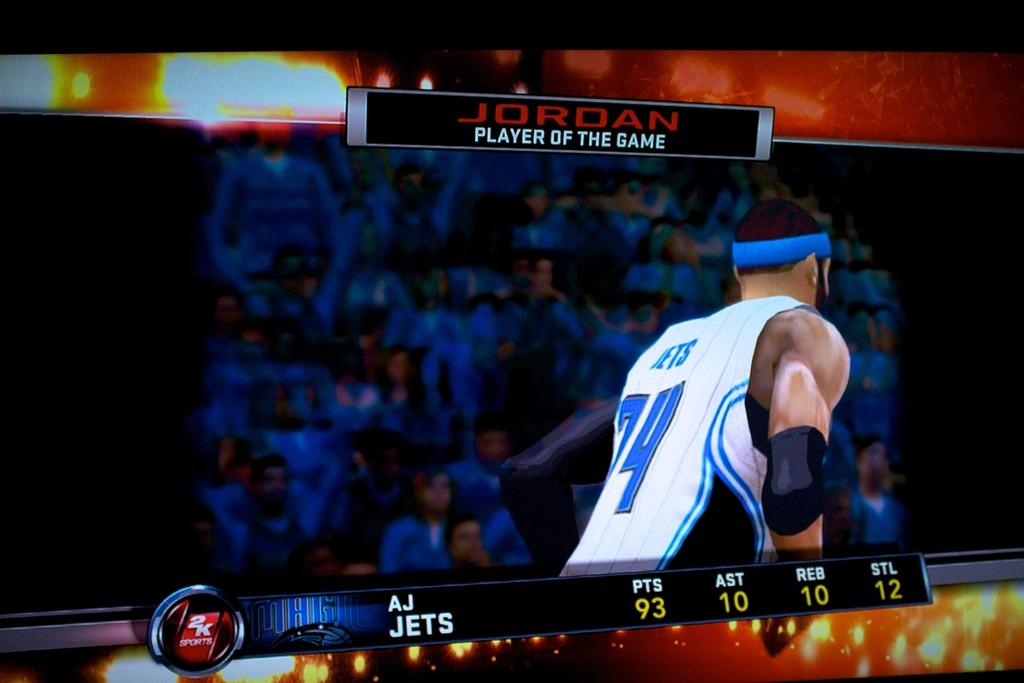What is the main subject of the image? The main subject of the image is an animated person wearing a white t-shirt. Where is the animated person located? The animated person is on a screen. What else can be seen in the image? There are groups of animated people in front of the man. What type of blade is being used by the animated person in the image? There is no blade present in the image; the animated person is not using any tool or object. 